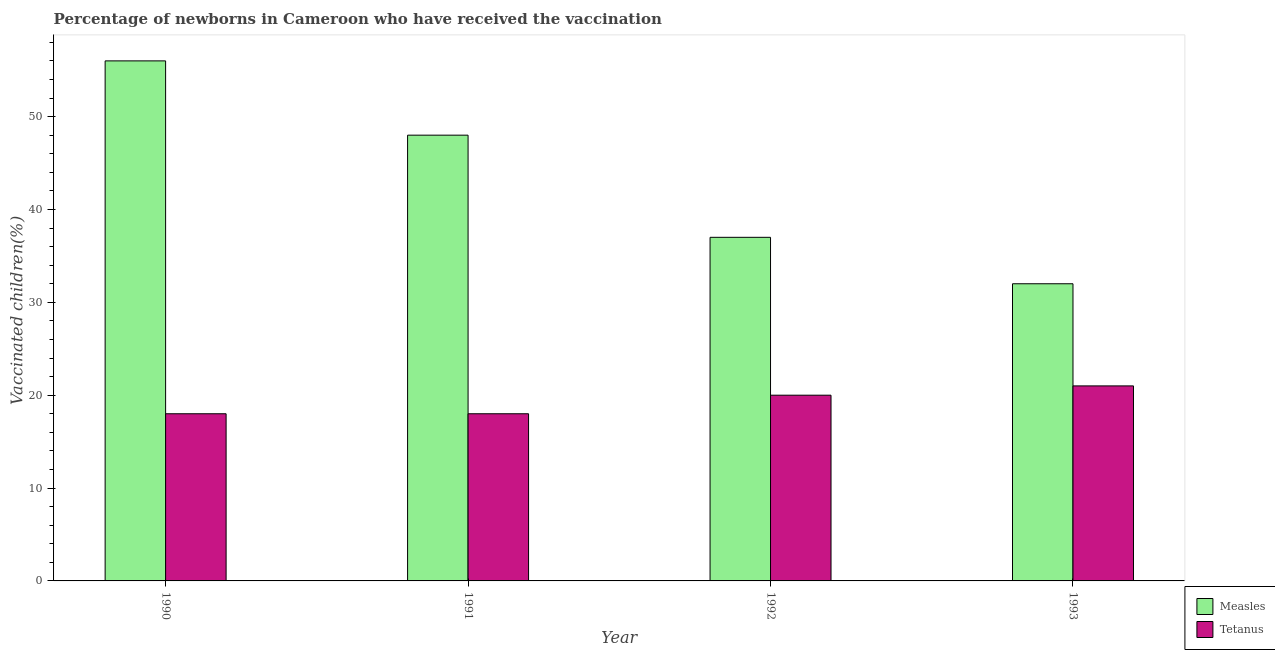How many different coloured bars are there?
Keep it short and to the point. 2. How many bars are there on the 3rd tick from the left?
Your answer should be compact. 2. In how many cases, is the number of bars for a given year not equal to the number of legend labels?
Your response must be concise. 0. What is the percentage of newborns who received vaccination for measles in 1993?
Provide a succinct answer. 32. Across all years, what is the maximum percentage of newborns who received vaccination for measles?
Provide a succinct answer. 56. Across all years, what is the minimum percentage of newborns who received vaccination for measles?
Provide a short and direct response. 32. What is the total percentage of newborns who received vaccination for measles in the graph?
Offer a terse response. 173. What is the difference between the percentage of newborns who received vaccination for measles in 1990 and that in 1991?
Your answer should be compact. 8. What is the difference between the percentage of newborns who received vaccination for tetanus in 1991 and the percentage of newborns who received vaccination for measles in 1993?
Make the answer very short. -3. What is the average percentage of newborns who received vaccination for measles per year?
Provide a succinct answer. 43.25. In the year 1992, what is the difference between the percentage of newborns who received vaccination for measles and percentage of newborns who received vaccination for tetanus?
Your answer should be very brief. 0. In how many years, is the percentage of newborns who received vaccination for measles greater than 4 %?
Make the answer very short. 4. What is the ratio of the percentage of newborns who received vaccination for tetanus in 1990 to that in 1992?
Give a very brief answer. 0.9. Is the percentage of newborns who received vaccination for tetanus in 1991 less than that in 1993?
Offer a terse response. Yes. Is the difference between the percentage of newborns who received vaccination for measles in 1992 and 1993 greater than the difference between the percentage of newborns who received vaccination for tetanus in 1992 and 1993?
Offer a very short reply. No. What is the difference between the highest and the lowest percentage of newborns who received vaccination for measles?
Keep it short and to the point. 24. Is the sum of the percentage of newborns who received vaccination for tetanus in 1990 and 1993 greater than the maximum percentage of newborns who received vaccination for measles across all years?
Your answer should be very brief. Yes. What does the 2nd bar from the left in 1991 represents?
Provide a succinct answer. Tetanus. What does the 1st bar from the right in 1992 represents?
Keep it short and to the point. Tetanus. How many bars are there?
Your response must be concise. 8. Are all the bars in the graph horizontal?
Ensure brevity in your answer.  No. Are the values on the major ticks of Y-axis written in scientific E-notation?
Your answer should be very brief. No. Does the graph contain any zero values?
Your answer should be compact. No. What is the title of the graph?
Ensure brevity in your answer.  Percentage of newborns in Cameroon who have received the vaccination. What is the label or title of the X-axis?
Provide a succinct answer. Year. What is the label or title of the Y-axis?
Give a very brief answer. Vaccinated children(%)
. What is the Vaccinated children(%)
 of Measles in 1990?
Make the answer very short. 56. What is the Vaccinated children(%)
 of Tetanus in 1991?
Provide a short and direct response. 18. What is the Vaccinated children(%)
 of Tetanus in 1992?
Make the answer very short. 20. Across all years, what is the maximum Vaccinated children(%)
 of Tetanus?
Your answer should be very brief. 21. Across all years, what is the minimum Vaccinated children(%)
 of Measles?
Make the answer very short. 32. What is the total Vaccinated children(%)
 in Measles in the graph?
Ensure brevity in your answer.  173. What is the total Vaccinated children(%)
 of Tetanus in the graph?
Make the answer very short. 77. What is the difference between the Vaccinated children(%)
 in Measles in 1990 and that in 1991?
Offer a terse response. 8. What is the difference between the Vaccinated children(%)
 of Tetanus in 1990 and that in 1991?
Your response must be concise. 0. What is the difference between the Vaccinated children(%)
 of Measles in 1990 and that in 1992?
Your response must be concise. 19. What is the difference between the Vaccinated children(%)
 in Tetanus in 1990 and that in 1992?
Ensure brevity in your answer.  -2. What is the difference between the Vaccinated children(%)
 of Measles in 1990 and that in 1993?
Your answer should be compact. 24. What is the difference between the Vaccinated children(%)
 in Tetanus in 1991 and that in 1992?
Your response must be concise. -2. What is the difference between the Vaccinated children(%)
 of Measles in 1991 and that in 1993?
Provide a short and direct response. 16. What is the difference between the Vaccinated children(%)
 of Tetanus in 1991 and that in 1993?
Offer a very short reply. -3. What is the difference between the Vaccinated children(%)
 in Tetanus in 1992 and that in 1993?
Your response must be concise. -1. What is the difference between the Vaccinated children(%)
 of Measles in 1990 and the Vaccinated children(%)
 of Tetanus in 1991?
Your answer should be compact. 38. What is the difference between the Vaccinated children(%)
 of Measles in 1990 and the Vaccinated children(%)
 of Tetanus in 1993?
Keep it short and to the point. 35. What is the difference between the Vaccinated children(%)
 in Measles in 1991 and the Vaccinated children(%)
 in Tetanus in 1992?
Offer a very short reply. 28. What is the difference between the Vaccinated children(%)
 in Measles in 1991 and the Vaccinated children(%)
 in Tetanus in 1993?
Ensure brevity in your answer.  27. What is the difference between the Vaccinated children(%)
 in Measles in 1992 and the Vaccinated children(%)
 in Tetanus in 1993?
Provide a succinct answer. 16. What is the average Vaccinated children(%)
 of Measles per year?
Ensure brevity in your answer.  43.25. What is the average Vaccinated children(%)
 of Tetanus per year?
Make the answer very short. 19.25. In the year 1990, what is the difference between the Vaccinated children(%)
 in Measles and Vaccinated children(%)
 in Tetanus?
Offer a terse response. 38. In the year 1992, what is the difference between the Vaccinated children(%)
 in Measles and Vaccinated children(%)
 in Tetanus?
Give a very brief answer. 17. What is the ratio of the Vaccinated children(%)
 of Measles in 1990 to that in 1992?
Keep it short and to the point. 1.51. What is the ratio of the Vaccinated children(%)
 in Tetanus in 1990 to that in 1992?
Your answer should be compact. 0.9. What is the ratio of the Vaccinated children(%)
 of Tetanus in 1990 to that in 1993?
Keep it short and to the point. 0.86. What is the ratio of the Vaccinated children(%)
 in Measles in 1991 to that in 1992?
Make the answer very short. 1.3. What is the ratio of the Vaccinated children(%)
 in Measles in 1992 to that in 1993?
Provide a succinct answer. 1.16. What is the ratio of the Vaccinated children(%)
 in Tetanus in 1992 to that in 1993?
Offer a very short reply. 0.95. What is the difference between the highest and the second highest Vaccinated children(%)
 in Measles?
Ensure brevity in your answer.  8. What is the difference between the highest and the lowest Vaccinated children(%)
 of Measles?
Provide a short and direct response. 24. What is the difference between the highest and the lowest Vaccinated children(%)
 of Tetanus?
Ensure brevity in your answer.  3. 